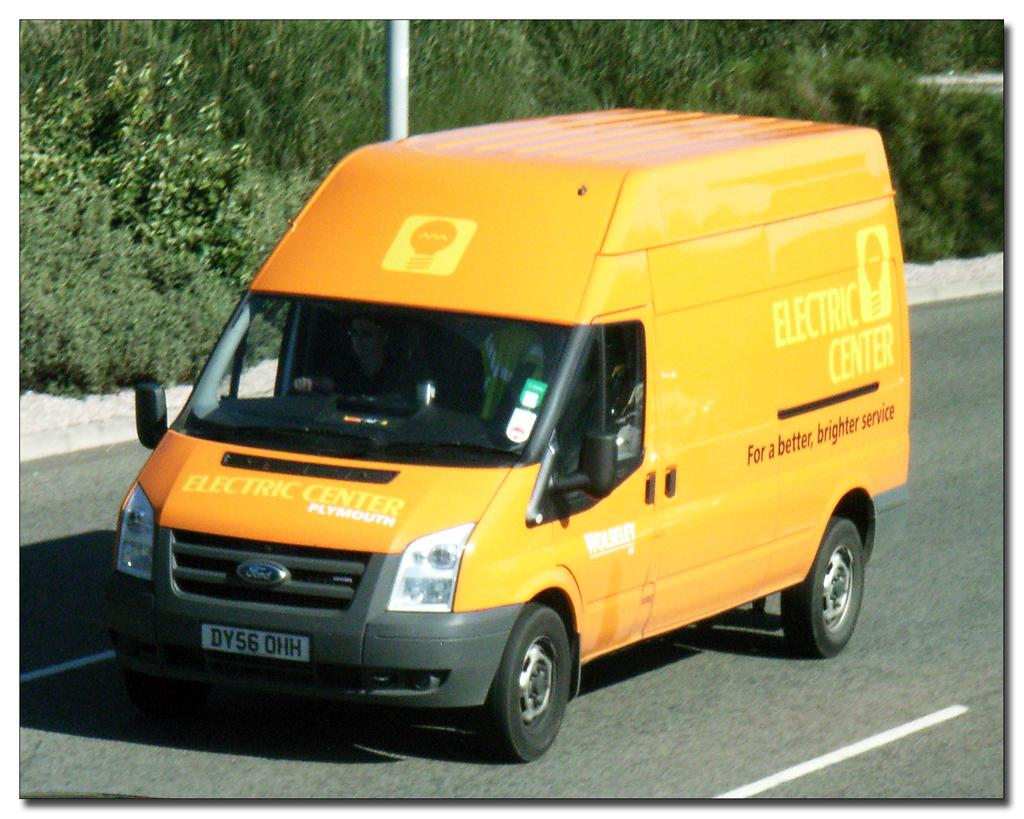<image>
Give a short and clear explanation of the subsequent image. An orange and yellow van from Electric Center drives down the road. 